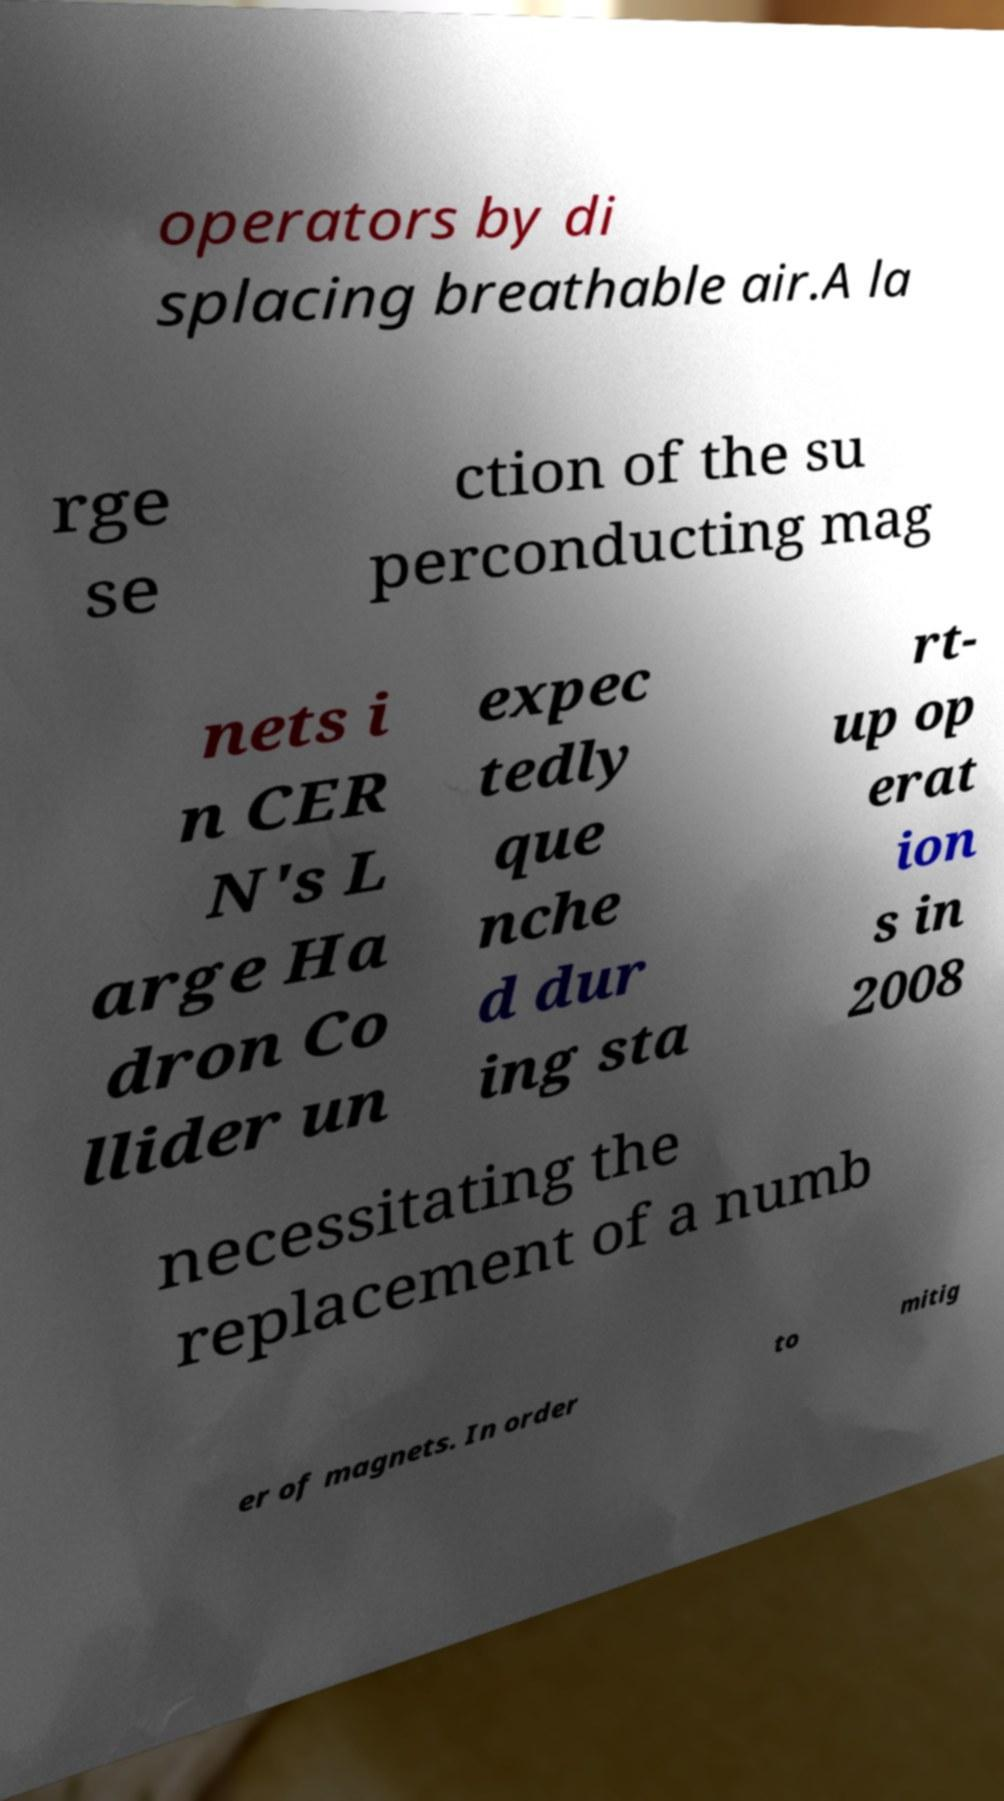Please read and relay the text visible in this image. What does it say? operators by di splacing breathable air.A la rge se ction of the su perconducting mag nets i n CER N's L arge Ha dron Co llider un expec tedly que nche d dur ing sta rt- up op erat ion s in 2008 necessitating the replacement of a numb er of magnets. In order to mitig 